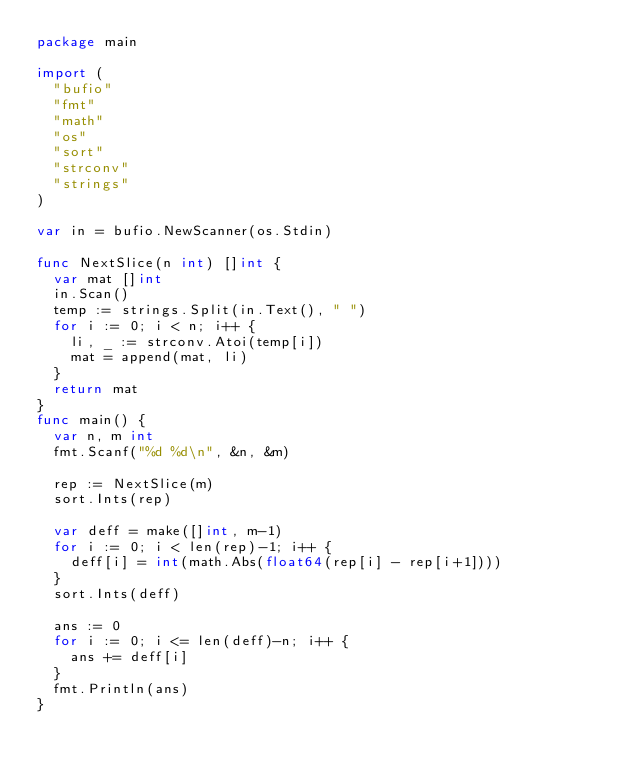<code> <loc_0><loc_0><loc_500><loc_500><_Go_>package main

import (
	"bufio"
	"fmt"
	"math"
	"os"
	"sort"
	"strconv"
	"strings"
)

var in = bufio.NewScanner(os.Stdin)

func NextSlice(n int) []int {
	var mat []int
	in.Scan()
	temp := strings.Split(in.Text(), " ")
	for i := 0; i < n; i++ {
		li, _ := strconv.Atoi(temp[i])
		mat = append(mat, li)
	}
	return mat
}
func main() {
	var n, m int
	fmt.Scanf("%d %d\n", &n, &m)

	rep := NextSlice(m)
	sort.Ints(rep)

	var deff = make([]int, m-1)
	for i := 0; i < len(rep)-1; i++ {
		deff[i] = int(math.Abs(float64(rep[i] - rep[i+1])))
	}
	sort.Ints(deff)

	ans := 0
	for i := 0; i <= len(deff)-n; i++ {
		ans += deff[i]
	}
	fmt.Println(ans)
}</code> 